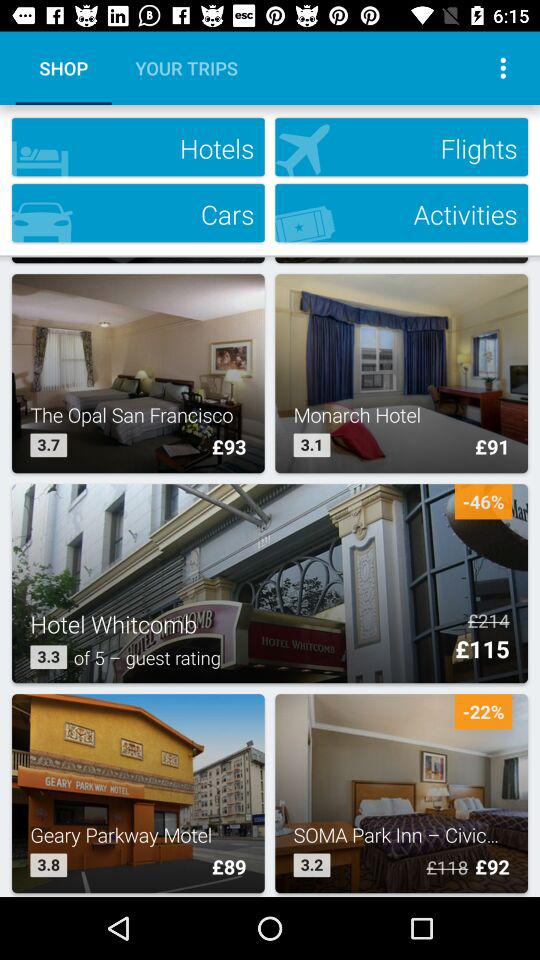What is the rating for "The Opal San Francisco"? The rating is 3.7. 